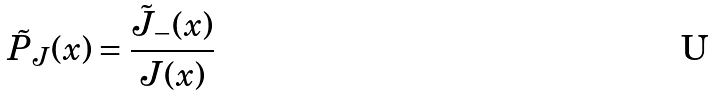<formula> <loc_0><loc_0><loc_500><loc_500>\tilde { P } _ { J } ( x ) = \frac { \tilde { J } _ { - } ( x ) } { J ( x ) }</formula> 